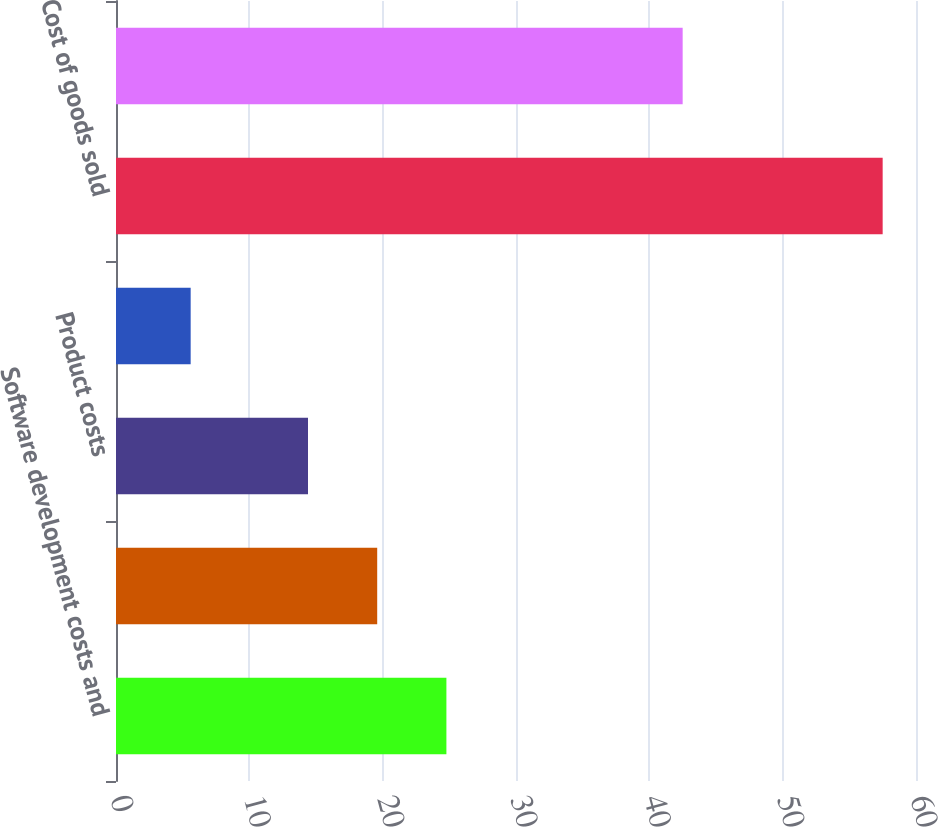<chart> <loc_0><loc_0><loc_500><loc_500><bar_chart><fcel>Software development costs and<fcel>Internal royalties<fcel>Product costs<fcel>Licenses<fcel>Cost of goods sold<fcel>Gross profit<nl><fcel>24.78<fcel>19.59<fcel>14.4<fcel>5.6<fcel>57.5<fcel>42.5<nl></chart> 